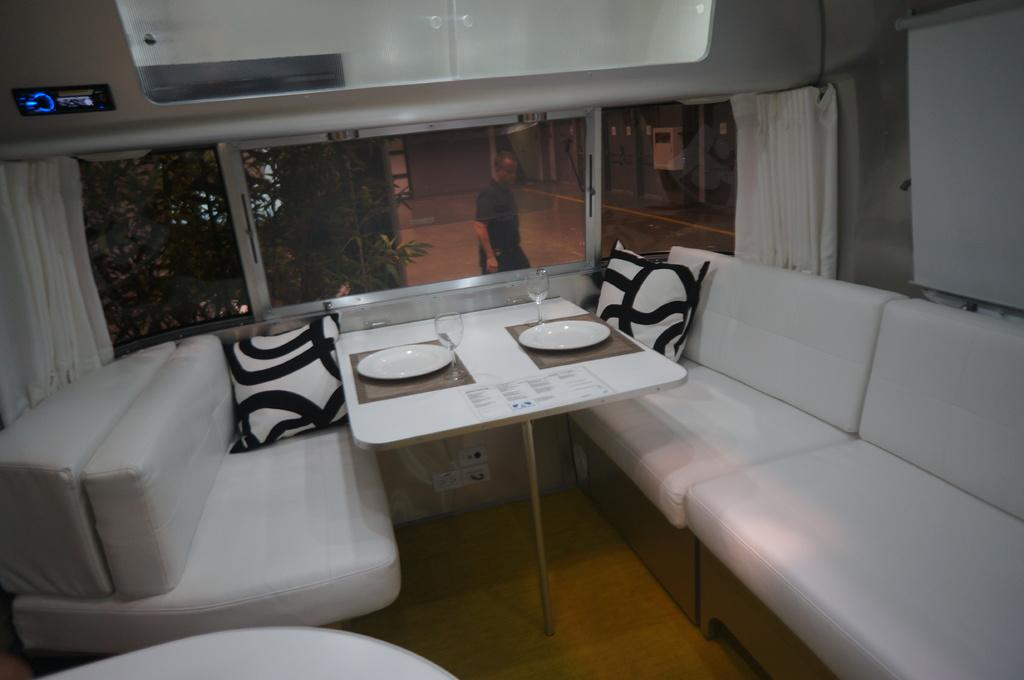What type of furniture is in the image? There is a sofa bed and a table in the image. What objects are on the table? There are two glasses and two plates on the table. Is there any greenery visible in the image? Yes, there is a plant visible through a window in the image. How does the robin use the wrench in the image? There is no robin or wrench present in the image. 